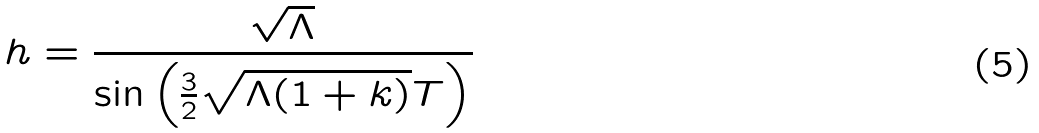Convert formula to latex. <formula><loc_0><loc_0><loc_500><loc_500>h = \frac { \sqrt { \Lambda } } { \sin \left ( \frac { 3 } { 2 } \sqrt { \Lambda ( 1 + k ) } T \right ) }</formula> 